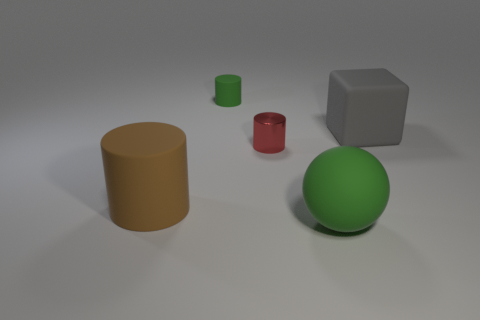What material is the red cylinder?
Offer a very short reply. Metal. What number of other objects are the same material as the big green sphere?
Ensure brevity in your answer.  3. What number of green blocks are there?
Offer a very short reply. 0. There is another brown thing that is the same shape as the small rubber thing; what is its material?
Your answer should be compact. Rubber. Does the big thing in front of the brown thing have the same material as the big cube?
Your response must be concise. Yes. Is the number of spheres right of the big gray rubber cube greater than the number of metallic cylinders to the left of the red object?
Offer a very short reply. No. What is the size of the ball?
Provide a succinct answer. Large. The gray object that is made of the same material as the green ball is what shape?
Keep it short and to the point. Cube. There is a green matte thing on the right side of the red cylinder; does it have the same shape as the small green matte thing?
Provide a succinct answer. No. How many things are either big purple cylinders or small red metallic things?
Offer a terse response. 1. 